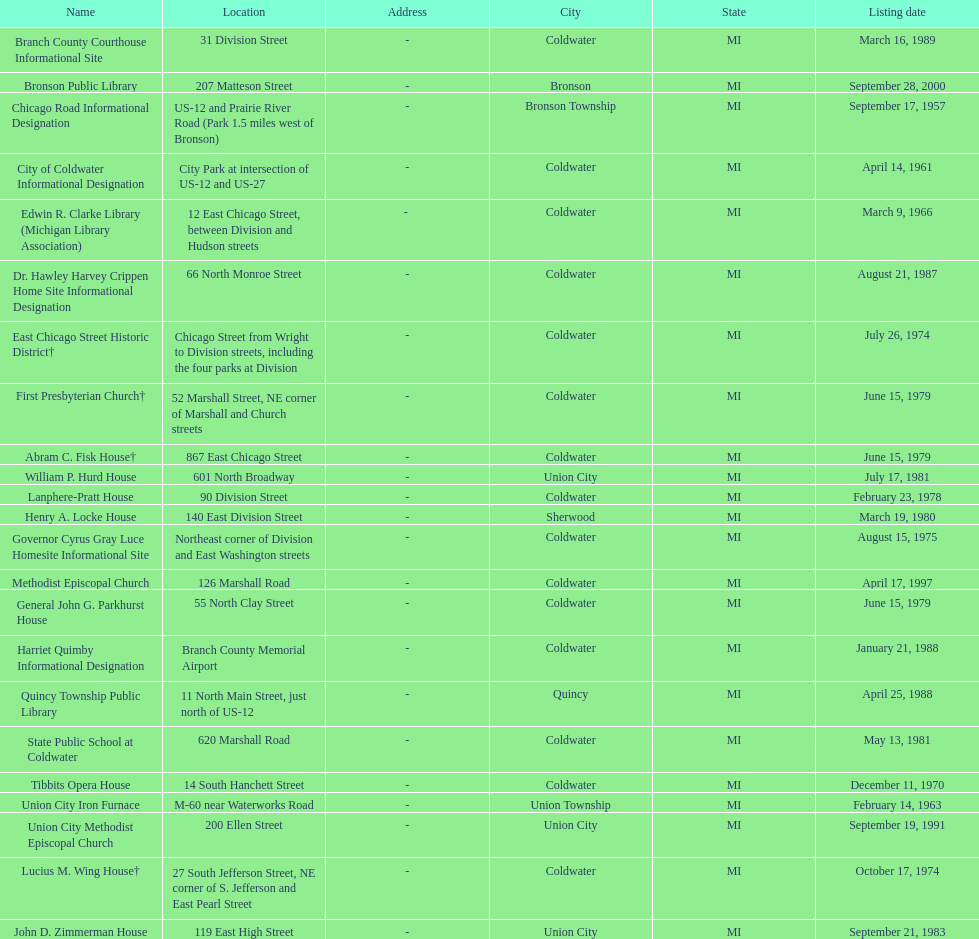Name a site that was listed no later than 1960. Chicago Road Informational Designation. 